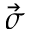<formula> <loc_0><loc_0><loc_500><loc_500>\vec { \sigma }</formula> 